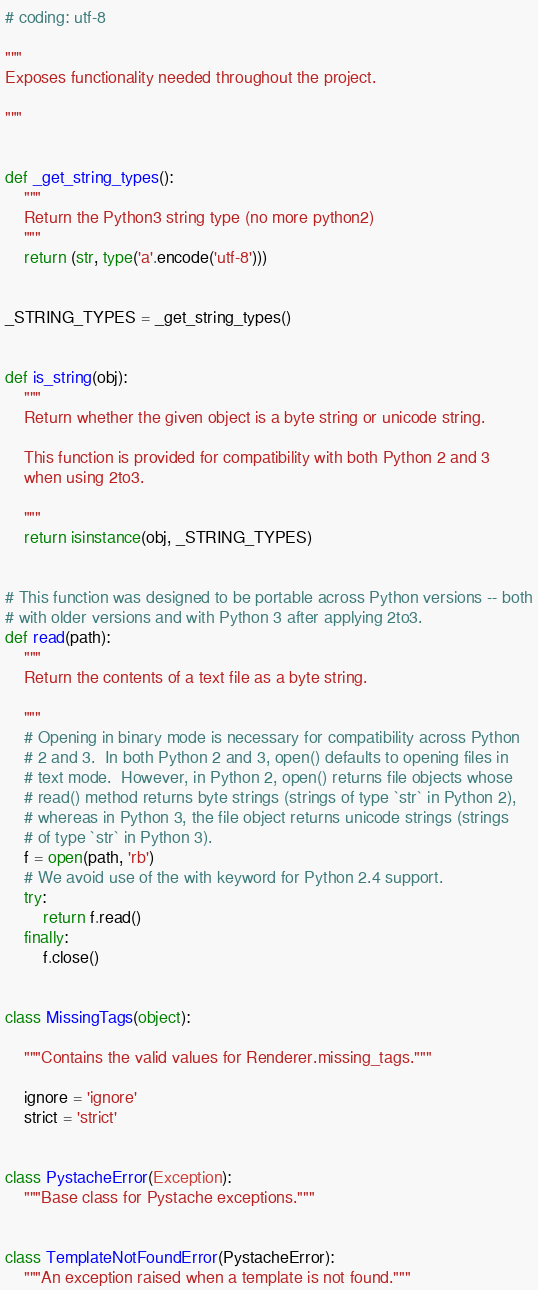<code> <loc_0><loc_0><loc_500><loc_500><_Python_># coding: utf-8

"""
Exposes functionality needed throughout the project.

"""


def _get_string_types():
    """
    Return the Python3 string type (no more python2)
    """
    return (str, type('a'.encode('utf-8')))


_STRING_TYPES = _get_string_types()


def is_string(obj):
    """
    Return whether the given object is a byte string or unicode string.

    This function is provided for compatibility with both Python 2 and 3
    when using 2to3.

    """
    return isinstance(obj, _STRING_TYPES)


# This function was designed to be portable across Python versions -- both
# with older versions and with Python 3 after applying 2to3.
def read(path):
    """
    Return the contents of a text file as a byte string.

    """
    # Opening in binary mode is necessary for compatibility across Python
    # 2 and 3.  In both Python 2 and 3, open() defaults to opening files in
    # text mode.  However, in Python 2, open() returns file objects whose
    # read() method returns byte strings (strings of type `str` in Python 2),
    # whereas in Python 3, the file object returns unicode strings (strings
    # of type `str` in Python 3).
    f = open(path, 'rb')
    # We avoid use of the with keyword for Python 2.4 support.
    try:
        return f.read()
    finally:
        f.close()


class MissingTags(object):

    """Contains the valid values for Renderer.missing_tags."""

    ignore = 'ignore'
    strict = 'strict'


class PystacheError(Exception):
    """Base class for Pystache exceptions."""


class TemplateNotFoundError(PystacheError):
    """An exception raised when a template is not found."""
</code> 